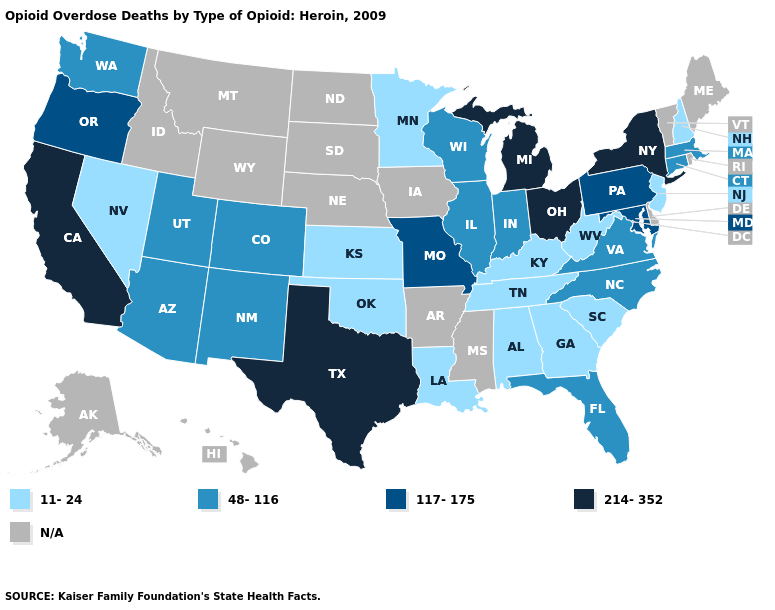What is the value of Nebraska?
Be succinct. N/A. Name the states that have a value in the range 11-24?
Concise answer only. Alabama, Georgia, Kansas, Kentucky, Louisiana, Minnesota, Nevada, New Hampshire, New Jersey, Oklahoma, South Carolina, Tennessee, West Virginia. Among the states that border Alabama , which have the highest value?
Be succinct. Florida. What is the highest value in states that border Nevada?
Keep it brief. 214-352. What is the highest value in states that border South Carolina?
Concise answer only. 48-116. Name the states that have a value in the range 214-352?
Quick response, please. California, Michigan, New York, Ohio, Texas. Name the states that have a value in the range 214-352?
Keep it brief. California, Michigan, New York, Ohio, Texas. Name the states that have a value in the range 48-116?
Be succinct. Arizona, Colorado, Connecticut, Florida, Illinois, Indiana, Massachusetts, New Mexico, North Carolina, Utah, Virginia, Washington, Wisconsin. Does Texas have the lowest value in the USA?
Answer briefly. No. Does the map have missing data?
Quick response, please. Yes. Among the states that border Mississippi , which have the highest value?
Keep it brief. Alabama, Louisiana, Tennessee. Name the states that have a value in the range N/A?
Quick response, please. Alaska, Arkansas, Delaware, Hawaii, Idaho, Iowa, Maine, Mississippi, Montana, Nebraska, North Dakota, Rhode Island, South Dakota, Vermont, Wyoming. 